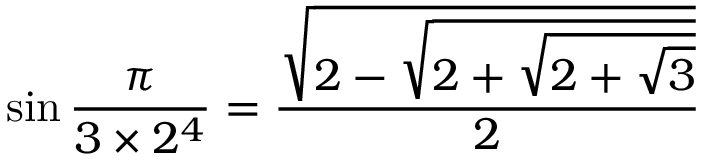Convert formula to latex. <formula><loc_0><loc_0><loc_500><loc_500>\sin { \frac { \pi } { 3 \times 2 ^ { 4 } } } = { \frac { \sqrt { 2 - { \sqrt { 2 + { \sqrt { 2 + { \sqrt { 3 } } } } } } } } { 2 } }</formula> 